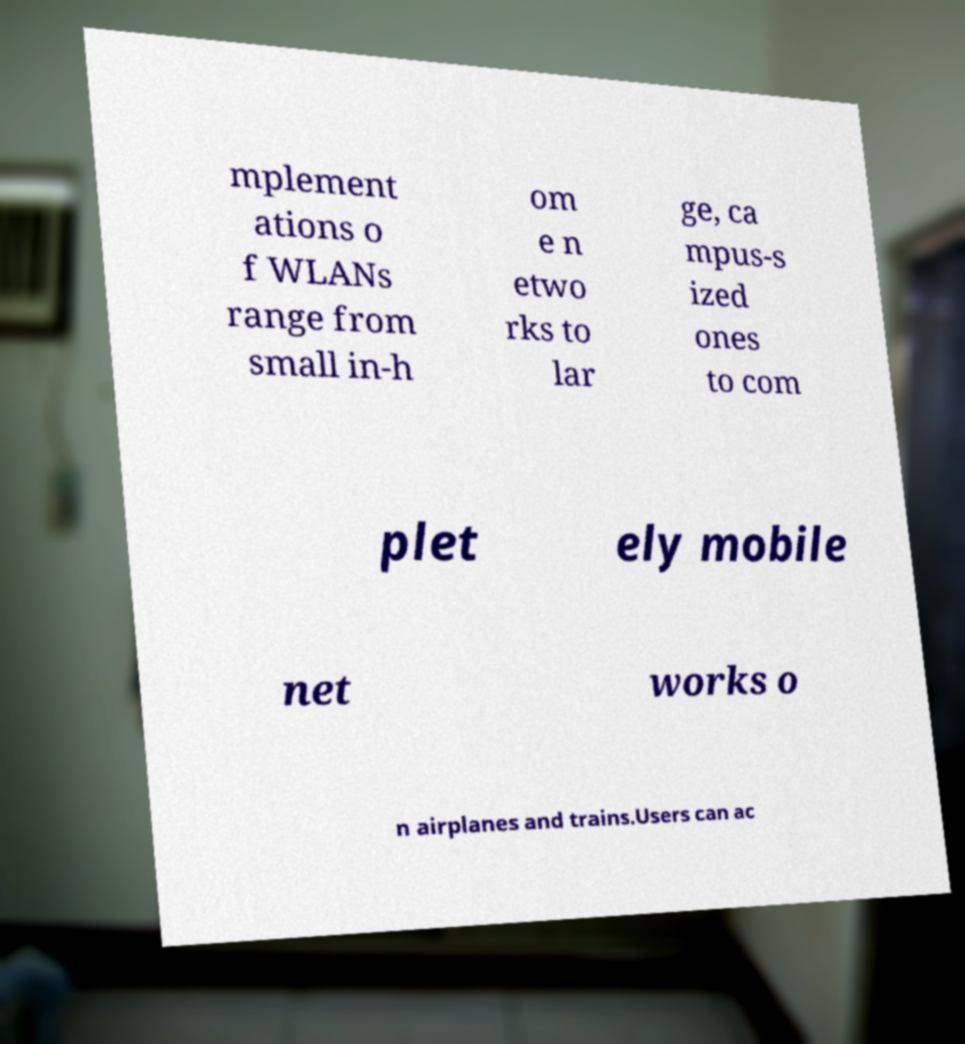Could you extract and type out the text from this image? mplement ations o f WLANs range from small in-h om e n etwo rks to lar ge, ca mpus-s ized ones to com plet ely mobile net works o n airplanes and trains.Users can ac 